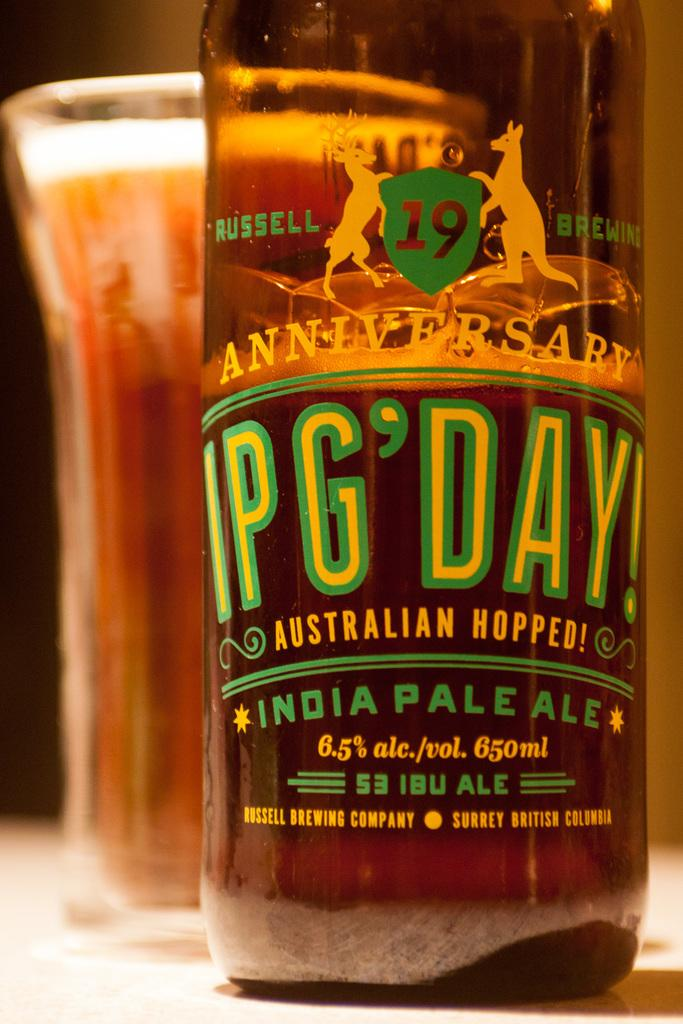What type of beverage is featured in the image? There is a wine bottle and a glass of wine in the image. Where are the wine bottle and glass of wine located? Both the wine bottle and glass of wine are on a table. What type of lawyer is depicted in the image? There is no lawyer depicted in the image; it only features a wine bottle and a glass of wine on a table. 